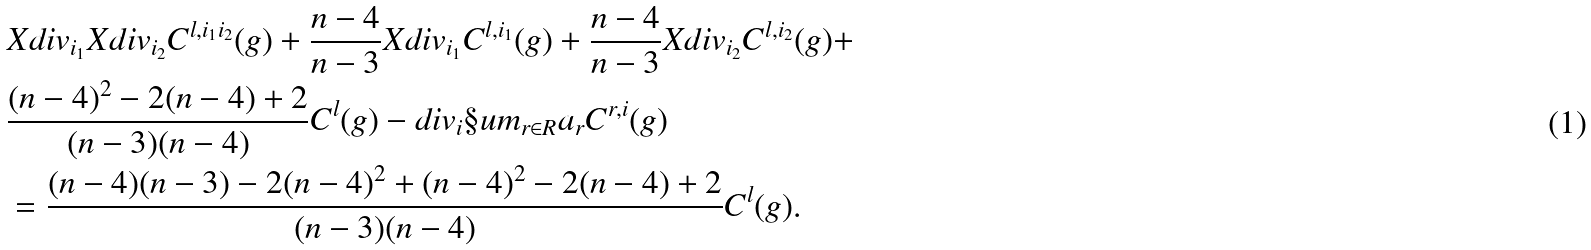Convert formula to latex. <formula><loc_0><loc_0><loc_500><loc_500>& X d i v _ { i _ { 1 } } X d i v _ { i _ { 2 } } C ^ { l , i _ { 1 } i _ { 2 } } ( g ) + \frac { n - 4 } { n - 3 } X d i v _ { i _ { 1 } } C ^ { l , i _ { 1 } } ( g ) + \frac { n - 4 } { n - 3 } X d i v _ { i _ { 2 } } C ^ { l , i _ { 2 } } ( g ) + \\ & \frac { ( n - 4 ) ^ { 2 } - 2 ( n - 4 ) + 2 } { ( n - 3 ) ( n - 4 ) } C ^ { l } ( g ) - d i v _ { i } \S u m _ { r \in R } a _ { r } C ^ { r , i } ( g ) \\ & = \frac { ( n - 4 ) ( n - 3 ) - 2 ( n - 4 ) ^ { 2 } + ( n - 4 ) ^ { 2 } - 2 ( n - 4 ) + 2 } { ( n - 3 ) ( n - 4 ) } C ^ { l } ( g ) .</formula> 